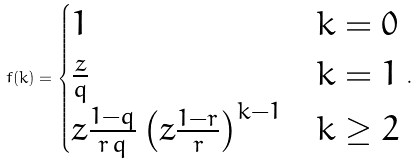Convert formula to latex. <formula><loc_0><loc_0><loc_500><loc_500>f ( k ) = \begin{cases} 1 & k = 0 \\ \frac { z } { q } & k = 1 \\ z \frac { 1 - q } { r \, q } \left ( z \frac { 1 - r } { r } \right ) ^ { k - 1 } & k \geq 2 \end{cases} \, .</formula> 